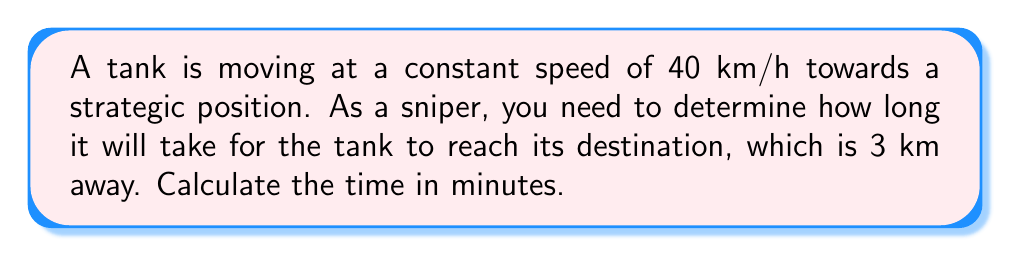Help me with this question. To solve this problem, we'll use the formula for time, distance, and speed:

$$\text{Time} = \frac{\text{Distance}}{\text{Speed}}$$

Let's break it down step-by-step:

1) We have:
   Distance = 3 km
   Speed = 40 km/h

2) Plug these values into the formula:
   $$\text{Time} = \frac{3 \text{ km}}{40 \text{ km/h}}$$

3) Simplify:
   $$\text{Time} = 0.075 \text{ hours}$$

4) Convert hours to minutes:
   $$0.075 \text{ hours} \times 60 \text{ minutes/hour} = 4.5 \text{ minutes}$$

Therefore, it will take the tank 4.5 minutes to reach its destination.
Answer: 4.5 minutes 